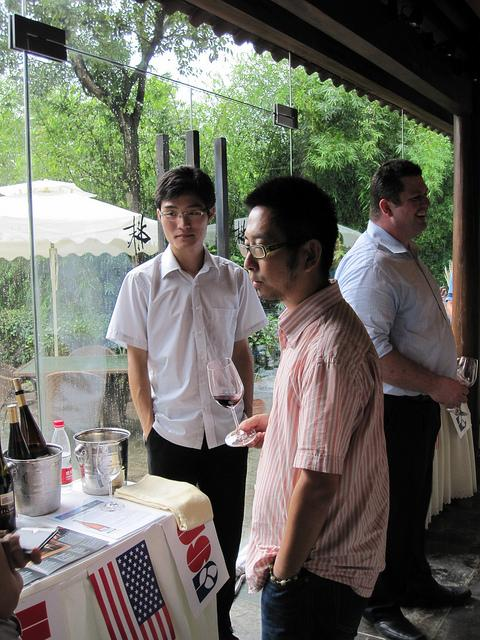What do two of the three men have on? Please explain your reasoning. glasses. The men have glasses. 